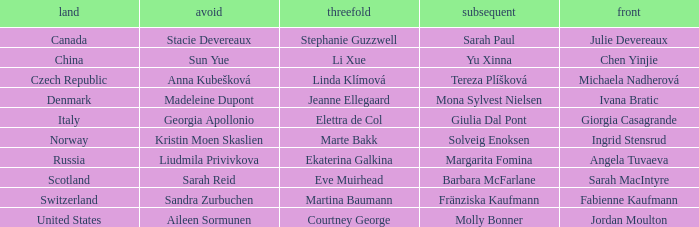What is the second that has jordan moulton as the lead? Molly Bonner. 